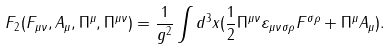Convert formula to latex. <formula><loc_0><loc_0><loc_500><loc_500>F _ { 2 } ( F _ { \mu \nu } , A _ { \mu } , \Pi ^ { \mu } , \Pi ^ { \mu \nu } ) = \frac { 1 } { g ^ { 2 } } \int d ^ { 3 } x ( \frac { 1 } { 2 } \Pi ^ { \mu \nu } \varepsilon _ { \mu \nu \sigma \rho } F ^ { \sigma \rho } + \Pi ^ { \mu } A _ { \mu } ) .</formula> 